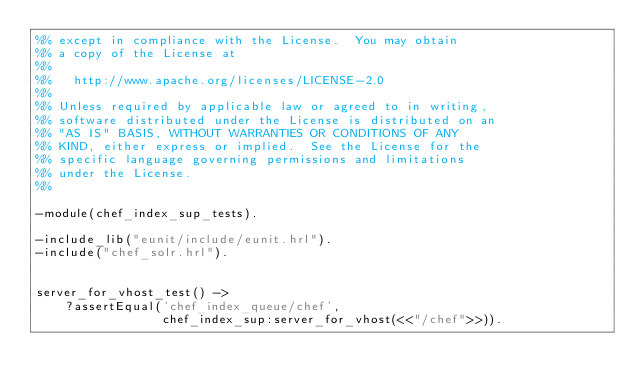Convert code to text. <code><loc_0><loc_0><loc_500><loc_500><_Erlang_>%% except in compliance with the License.  You may obtain
%% a copy of the License at
%%
%%   http://www.apache.org/licenses/LICENSE-2.0
%%
%% Unless required by applicable law or agreed to in writing,
%% software distributed under the License is distributed on an
%% "AS IS" BASIS, WITHOUT WARRANTIES OR CONDITIONS OF ANY
%% KIND, either express or implied.  See the License for the
%% specific language governing permissions and limitations
%% under the License.
%%

-module(chef_index_sup_tests).

-include_lib("eunit/include/eunit.hrl").
-include("chef_solr.hrl").


server_for_vhost_test() ->
    ?assertEqual('chef_index_queue/chef',
                 chef_index_sup:server_for_vhost(<<"/chef">>)).
</code> 